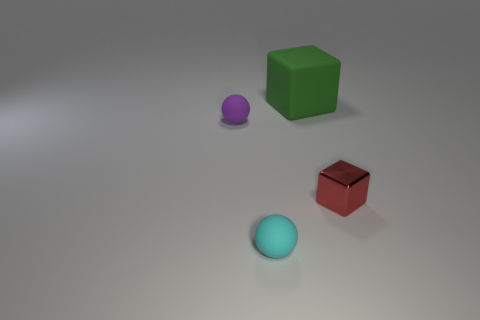Add 4 big red rubber spheres. How many objects exist? 8 Add 1 purple rubber objects. How many purple rubber objects exist? 2 Subtract 0 brown spheres. How many objects are left? 4 Subtract all rubber things. Subtract all green cubes. How many objects are left? 0 Add 3 large green objects. How many large green objects are left? 4 